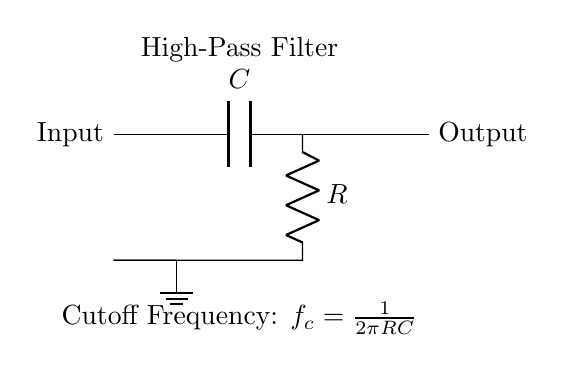What is the component labeled C? The component labeled C in the circuit is a capacitor, which stores electrical energy temporarily.
Answer: Capacitor What is the component labeled R? The component labeled R in the circuit is a resistor, which restricts the flow of electric current.
Answer: Resistor What is the function of this circuit? This circuit functions as a high-pass filter, allowing signals with a frequency higher than a specified cutoff frequency to pass while attenuating lower frequencies.
Answer: High-pass filter What is the cutoff frequency formula given in the diagram? The cutoff frequency formula provided in the diagram is \( f_c = \frac{1}{2\pi RC} \), which shows how the cutoff frequency depends on both the resistor and capacitor values.
Answer: \( f_c = \frac{1}{2\pi RC} \) What does the input node connect to? The input node connects directly to the capacitor, which indicates that the incoming signal first passes through this component before proceeding to the rest of the circuit.
Answer: Capacitor How does changing the value of R affect the cutoff frequency? Increasing the resistance R will lower the cutoff frequency, while decreasing R will raise it, as indicated by the inverse relationship in the cutoff frequency formula.
Answer: Inverse relationship What type of signal does this circuit primarily filter? This circuit primarily filters low-frequency noise, allowing higher frequency audio signals to be recorded clearly in voice recorders.
Answer: Low-frequency noise 